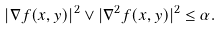<formula> <loc_0><loc_0><loc_500><loc_500>| \nabla f ( x , y ) | ^ { 2 } \vee | \nabla ^ { 2 } f ( x , y ) | ^ { 2 } \leq \alpha .</formula> 